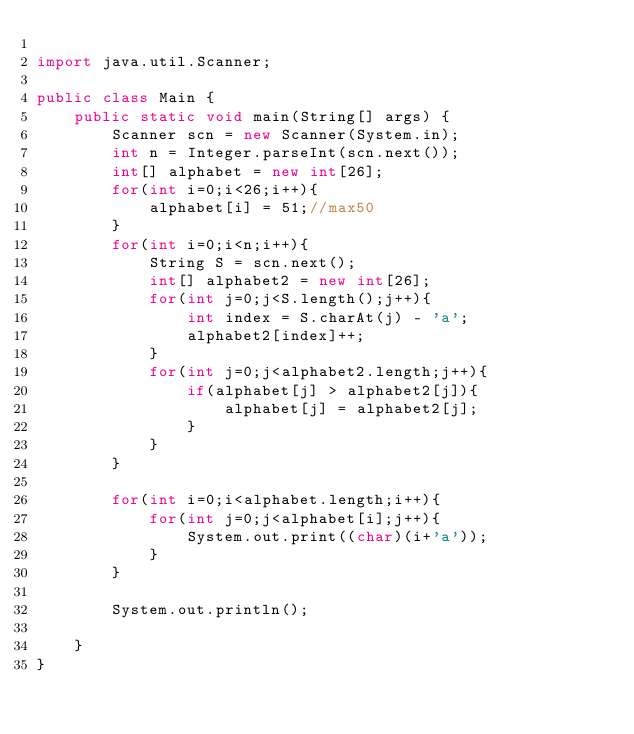Convert code to text. <code><loc_0><loc_0><loc_500><loc_500><_Java_>
import java.util.Scanner;

public class Main {
	public static void main(String[] args) {
		Scanner scn = new Scanner(System.in);
		int n = Integer.parseInt(scn.next());
		int[] alphabet = new int[26];
		for(int i=0;i<26;i++){
			alphabet[i] = 51;//max50
		}
		for(int i=0;i<n;i++){
			String S = scn.next();
			int[] alphabet2 = new int[26];
			for(int j=0;j<S.length();j++){
				int index = S.charAt(j) - 'a';
				alphabet2[index]++;
			}
			for(int j=0;j<alphabet2.length;j++){
				if(alphabet[j] > alphabet2[j]){
					alphabet[j] = alphabet2[j];
				}
			}
		}

		for(int i=0;i<alphabet.length;i++){
			for(int j=0;j<alphabet[i];j++){
				System.out.print((char)(i+'a'));
			}
		}

		System.out.println();

    }
}</code> 